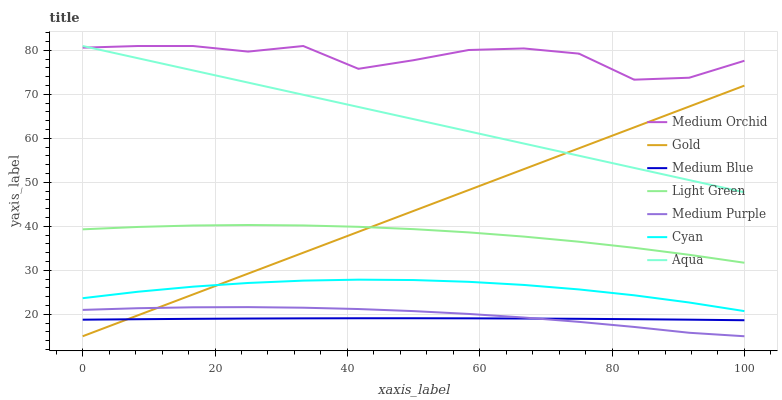Does Medium Blue have the minimum area under the curve?
Answer yes or no. Yes. Does Medium Orchid have the maximum area under the curve?
Answer yes or no. Yes. Does Aqua have the minimum area under the curve?
Answer yes or no. No. Does Aqua have the maximum area under the curve?
Answer yes or no. No. Is Gold the smoothest?
Answer yes or no. Yes. Is Medium Orchid the roughest?
Answer yes or no. Yes. Is Aqua the smoothest?
Answer yes or no. No. Is Aqua the roughest?
Answer yes or no. No. Does Gold have the lowest value?
Answer yes or no. Yes. Does Aqua have the lowest value?
Answer yes or no. No. Does Medium Orchid have the highest value?
Answer yes or no. Yes. Does Medium Blue have the highest value?
Answer yes or no. No. Is Cyan less than Aqua?
Answer yes or no. Yes. Is Medium Orchid greater than Light Green?
Answer yes or no. Yes. Does Medium Purple intersect Medium Blue?
Answer yes or no. Yes. Is Medium Purple less than Medium Blue?
Answer yes or no. No. Is Medium Purple greater than Medium Blue?
Answer yes or no. No. Does Cyan intersect Aqua?
Answer yes or no. No. 